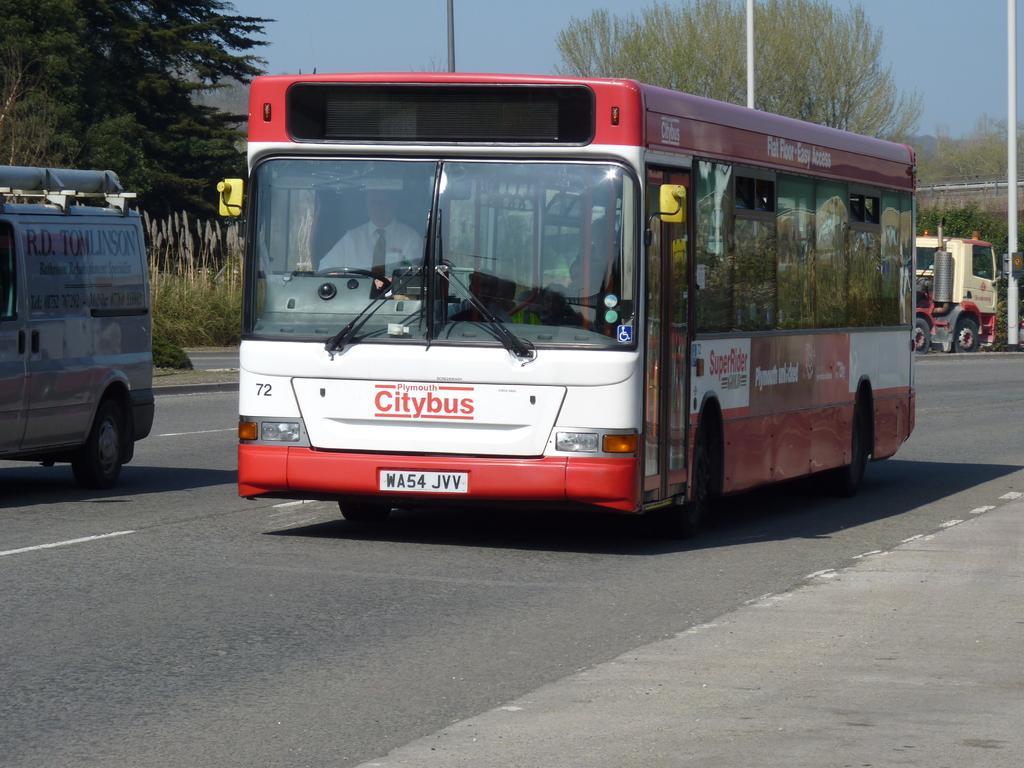In one or two sentences, can you explain what this image depicts? In this image I can see a road in the front and on it I can see few vehicles. On these vehicles I can see something is written. In the background I can see number of trees, few poles and the sky. 